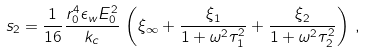Convert formula to latex. <formula><loc_0><loc_0><loc_500><loc_500>s _ { 2 } = \frac { 1 } { 1 6 } \frac { r _ { 0 } ^ { 4 } \epsilon _ { w } E _ { 0 } ^ { 2 } } { k _ { c } } \, \left ( \xi _ { \infty } + \frac { \xi _ { 1 } } { 1 + \omega ^ { 2 } \tau _ { 1 } ^ { 2 } } + \frac { \xi _ { 2 } } { 1 + \omega ^ { 2 } \tau _ { 2 } ^ { 2 } } \right ) \, ,</formula> 